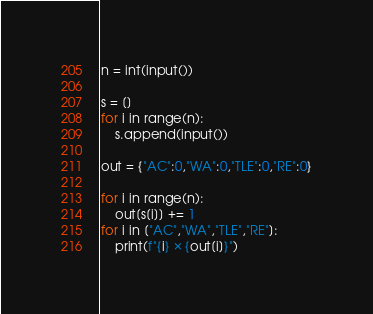<code> <loc_0><loc_0><loc_500><loc_500><_Python_>n = int(input())

s = []
for i in range(n):
    s.append(input())

out = {"AC":0,"WA":0,"TLE":0,"RE":0}

for i in range(n):
    out[s[i]] += 1
for i in ["AC","WA","TLE","RE"]:
    print(f"{i} × {out[i]}") 
</code> 